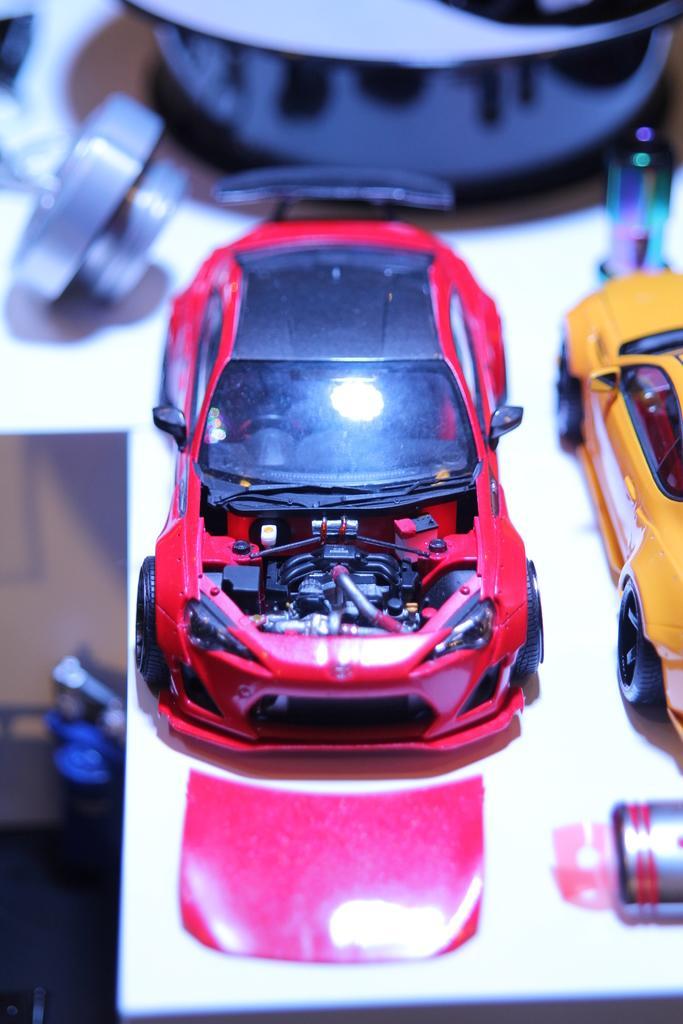Describe this image in one or two sentences. In this picture we can able to see two toy cars one is of red in color and another one is of yellow in color. 